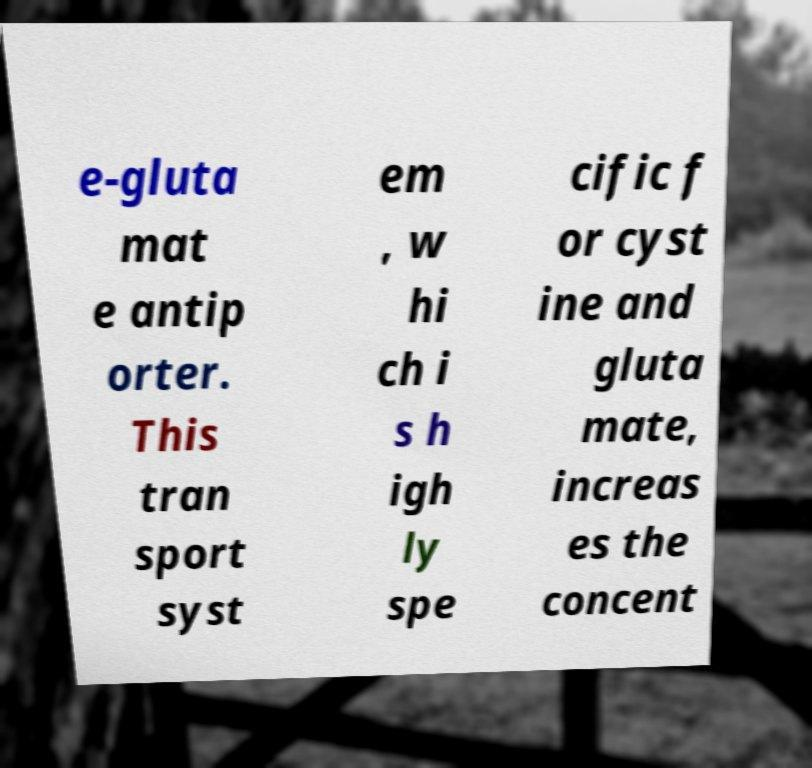Can you accurately transcribe the text from the provided image for me? e-gluta mat e antip orter. This tran sport syst em , w hi ch i s h igh ly spe cific f or cyst ine and gluta mate, increas es the concent 